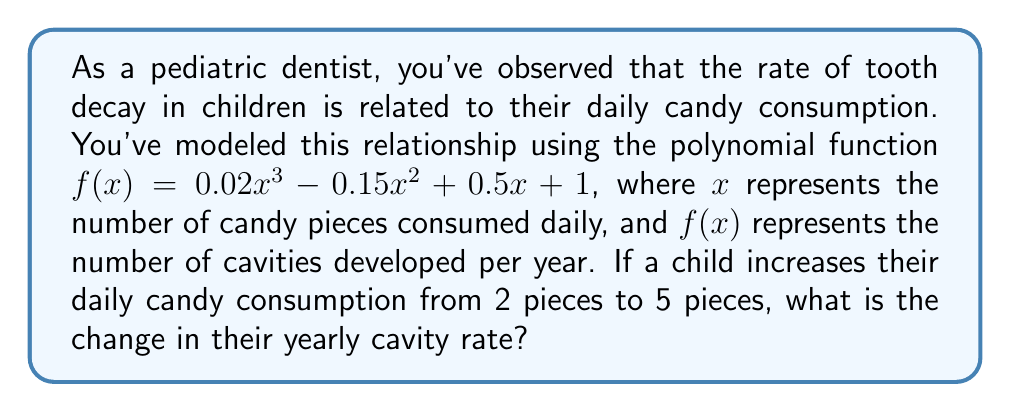Help me with this question. To solve this problem, we need to:
1. Calculate the cavity rate for 2 pieces of candy per day
2. Calculate the cavity rate for 5 pieces of candy per day
3. Find the difference between these two rates

Step 1: Cavity rate for 2 pieces of candy per day
$$\begin{align}
f(2) &= 0.02(2)^3 - 0.15(2)^2 + 0.5(2) + 1 \\
&= 0.02(8) - 0.15(4) + 1 + 1 \\
&= 0.16 - 0.6 + 2 \\
&= 1.56 \text{ cavities per year}
\end{align}$$

Step 2: Cavity rate for 5 pieces of candy per day
$$\begin{align}
f(5) &= 0.02(5)^3 - 0.15(5)^2 + 0.5(5) + 1 \\
&= 0.02(125) - 0.15(25) + 2.5 + 1 \\
&= 2.5 - 3.75 + 3.5 \\
&= 2.25 \text{ cavities per year}
\end{align}$$

Step 3: Change in cavity rate
$$\begin{align}
\text{Change} &= f(5) - f(2) \\
&= 2.25 - 1.56 \\
&= 0.69 \text{ cavities per year}
\end{align}$$
Answer: The change in yearly cavity rate is an increase of 0.69 cavities per year. 